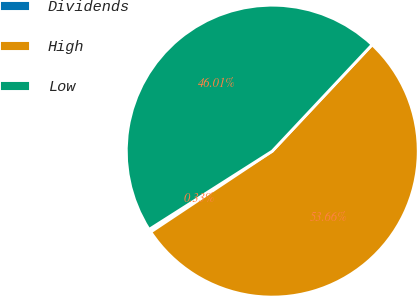Convert chart to OTSL. <chart><loc_0><loc_0><loc_500><loc_500><pie_chart><fcel>Dividends<fcel>High<fcel>Low<nl><fcel>0.33%<fcel>53.66%<fcel>46.01%<nl></chart> 